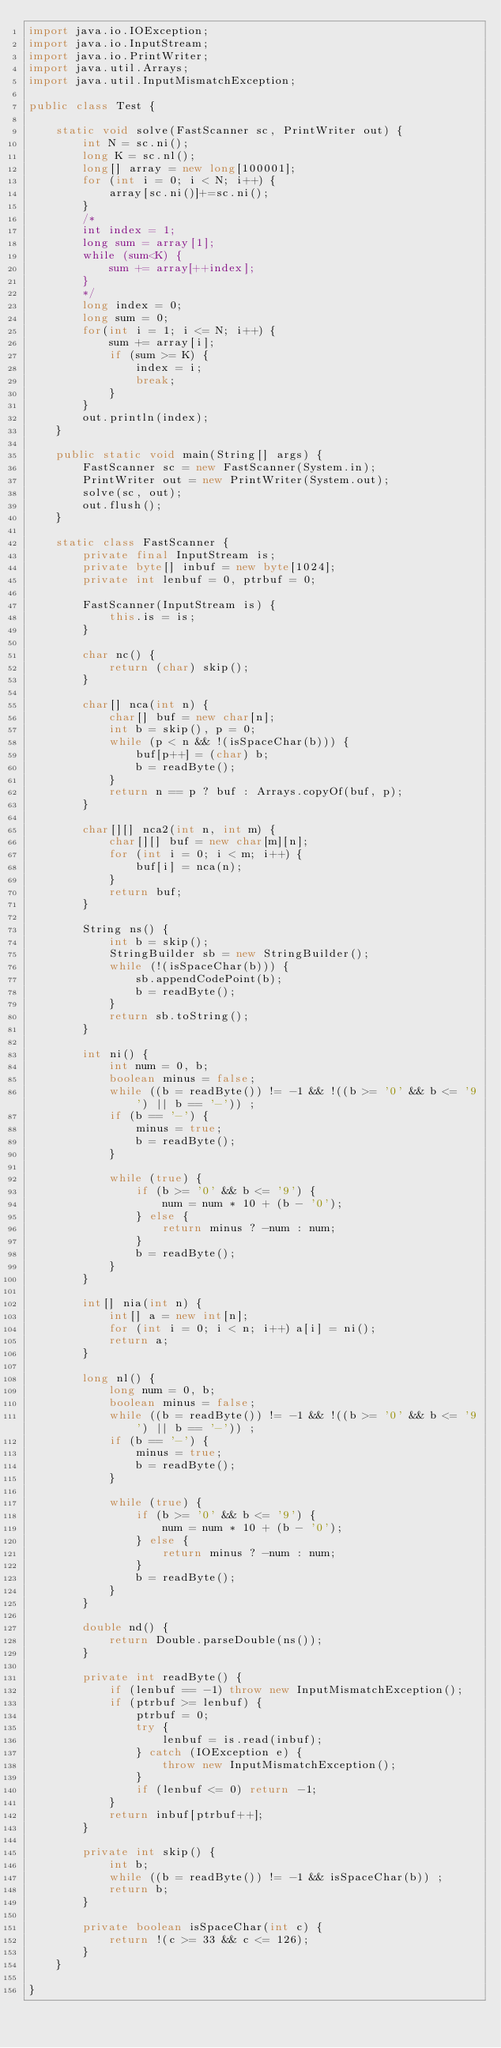<code> <loc_0><loc_0><loc_500><loc_500><_Java_>import java.io.IOException;
import java.io.InputStream;
import java.io.PrintWriter;
import java.util.Arrays;
import java.util.InputMismatchException;

public class Test {

    static void solve(FastScanner sc, PrintWriter out) {
        int N = sc.ni();
        long K = sc.nl();
        long[] array = new long[100001];
        for (int i = 0; i < N; i++) {
            array[sc.ni()]+=sc.ni();
        }
        /*
        int index = 1;
        long sum = array[1];
        while (sum<K) {
            sum += array[++index];
        }
        */
        long index = 0;
        long sum = 0;
        for(int i = 1; i <= N; i++) {
			sum += array[i];
			if (sum >= K) {
				index = i;
				break;
			}
        }
        out.println(index);
    }

    public static void main(String[] args) {
        FastScanner sc = new FastScanner(System.in);
        PrintWriter out = new PrintWriter(System.out);
        solve(sc, out);
        out.flush();
    }

    static class FastScanner {
        private final InputStream is;
        private byte[] inbuf = new byte[1024];
        private int lenbuf = 0, ptrbuf = 0;

        FastScanner(InputStream is) {
            this.is = is;
        }

        char nc() {
            return (char) skip();
        }

        char[] nca(int n) {
            char[] buf = new char[n];
            int b = skip(), p = 0;
            while (p < n && !(isSpaceChar(b))) {
                buf[p++] = (char) b;
                b = readByte();
            }
            return n == p ? buf : Arrays.copyOf(buf, p);
        }

        char[][] nca2(int n, int m) {
            char[][] buf = new char[m][n];
            for (int i = 0; i < m; i++) {
                buf[i] = nca(n);
            }
            return buf;
        }

        String ns() {
            int b = skip();
            StringBuilder sb = new StringBuilder();
            while (!(isSpaceChar(b))) {
                sb.appendCodePoint(b);
                b = readByte();
            }
            return sb.toString();
        }

        int ni() {
            int num = 0, b;
            boolean minus = false;
            while ((b = readByte()) != -1 && !((b >= '0' && b <= '9') || b == '-')) ;
            if (b == '-') {
                minus = true;
                b = readByte();
            }

            while (true) {
                if (b >= '0' && b <= '9') {
                    num = num * 10 + (b - '0');
                } else {
                    return minus ? -num : num;
                }
                b = readByte();
            }
        }

        int[] nia(int n) {
            int[] a = new int[n];
            for (int i = 0; i < n; i++) a[i] = ni();
            return a;
        }

        long nl() {
            long num = 0, b;
            boolean minus = false;
            while ((b = readByte()) != -1 && !((b >= '0' && b <= '9') || b == '-')) ;
            if (b == '-') {
                minus = true;
                b = readByte();
            }

            while (true) {
                if (b >= '0' && b <= '9') {
                    num = num * 10 + (b - '0');
                } else {
                    return minus ? -num : num;
                }
                b = readByte();
            }
        }

        double nd() {
            return Double.parseDouble(ns());
        }

        private int readByte() {
            if (lenbuf == -1) throw new InputMismatchException();
            if (ptrbuf >= lenbuf) {
                ptrbuf = 0;
                try {
                    lenbuf = is.read(inbuf);
                } catch (IOException e) {
                    throw new InputMismatchException();
                }
                if (lenbuf <= 0) return -1;
            }
            return inbuf[ptrbuf++];
        }

        private int skip() {
            int b;
            while ((b = readByte()) != -1 && isSpaceChar(b)) ;
            return b;
        }

        private boolean isSpaceChar(int c) {
            return !(c >= 33 && c <= 126);
        }
    }

}
</code> 